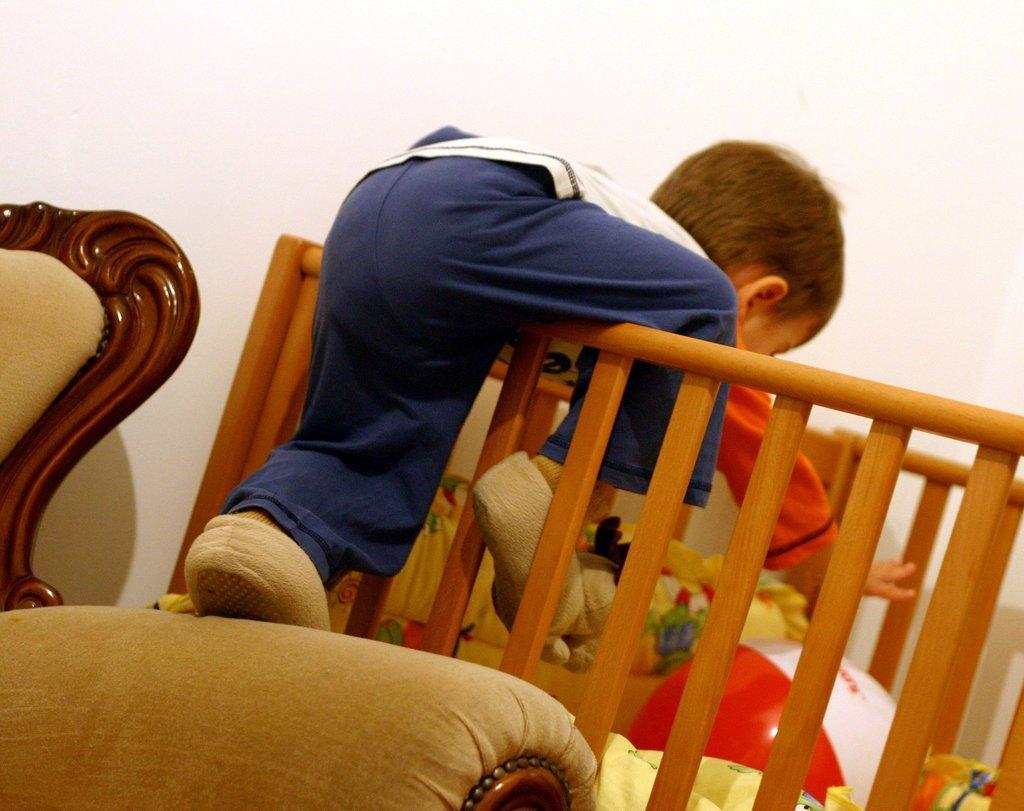Can you describe this image briefly? In this image I see a baby's crib over here and I see ball over here which is of red and white in color and I see a boy on this crib and I see the couch over here. In the background I see the white wall. 